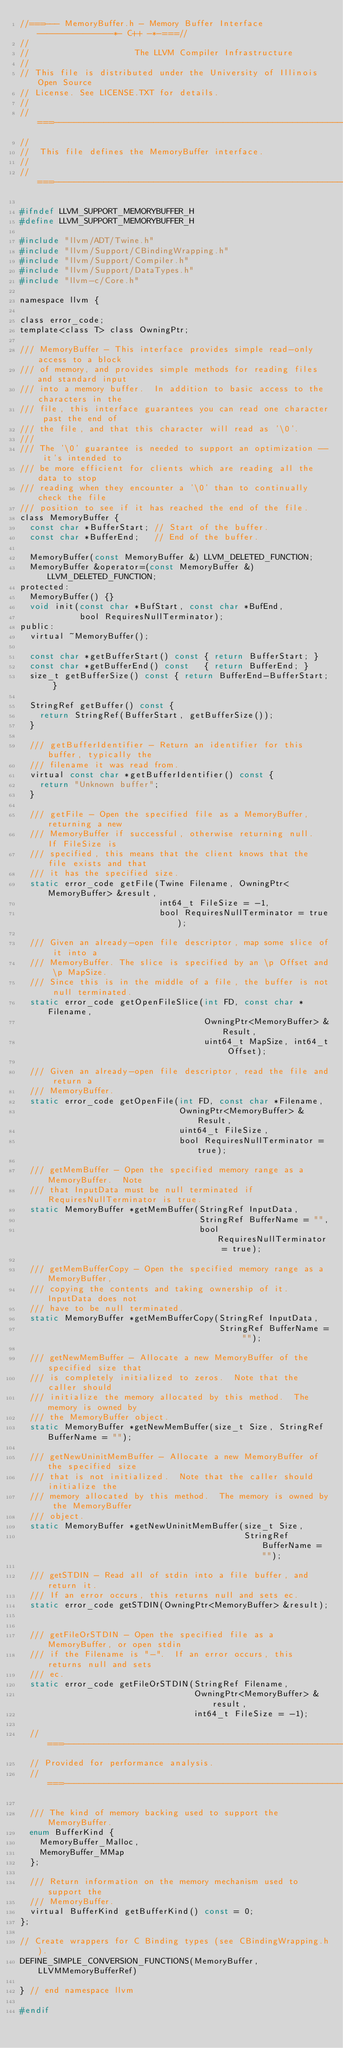<code> <loc_0><loc_0><loc_500><loc_500><_C_>//===--- MemoryBuffer.h - Memory Buffer Interface ---------------*- C++ -*-===//
//
//                     The LLVM Compiler Infrastructure
//
// This file is distributed under the University of Illinois Open Source
// License. See LICENSE.TXT for details.
//
//===----------------------------------------------------------------------===//
//
//  This file defines the MemoryBuffer interface.
//
//===----------------------------------------------------------------------===//

#ifndef LLVM_SUPPORT_MEMORYBUFFER_H
#define LLVM_SUPPORT_MEMORYBUFFER_H

#include "llvm/ADT/Twine.h"
#include "llvm/Support/CBindingWrapping.h"
#include "llvm/Support/Compiler.h"
#include "llvm/Support/DataTypes.h"
#include "llvm-c/Core.h"

namespace llvm {

class error_code;
template<class T> class OwningPtr;

/// MemoryBuffer - This interface provides simple read-only access to a block
/// of memory, and provides simple methods for reading files and standard input
/// into a memory buffer.  In addition to basic access to the characters in the
/// file, this interface guarantees you can read one character past the end of
/// the file, and that this character will read as '\0'.
///
/// The '\0' guarantee is needed to support an optimization -- it's intended to
/// be more efficient for clients which are reading all the data to stop
/// reading when they encounter a '\0' than to continually check the file
/// position to see if it has reached the end of the file.
class MemoryBuffer {
  const char *BufferStart; // Start of the buffer.
  const char *BufferEnd;   // End of the buffer.

  MemoryBuffer(const MemoryBuffer &) LLVM_DELETED_FUNCTION;
  MemoryBuffer &operator=(const MemoryBuffer &) LLVM_DELETED_FUNCTION;
protected:
  MemoryBuffer() {}
  void init(const char *BufStart, const char *BufEnd,
            bool RequiresNullTerminator);
public:
  virtual ~MemoryBuffer();

  const char *getBufferStart() const { return BufferStart; }
  const char *getBufferEnd() const   { return BufferEnd; }
  size_t getBufferSize() const { return BufferEnd-BufferStart; }

  StringRef getBuffer() const {
    return StringRef(BufferStart, getBufferSize());
  }

  /// getBufferIdentifier - Return an identifier for this buffer, typically the
  /// filename it was read from.
  virtual const char *getBufferIdentifier() const {
    return "Unknown buffer";
  }

  /// getFile - Open the specified file as a MemoryBuffer, returning a new
  /// MemoryBuffer if successful, otherwise returning null.  If FileSize is
  /// specified, this means that the client knows that the file exists and that
  /// it has the specified size.
  static error_code getFile(Twine Filename, OwningPtr<MemoryBuffer> &result,
                            int64_t FileSize = -1,
                            bool RequiresNullTerminator = true);

  /// Given an already-open file descriptor, map some slice of it into a
  /// MemoryBuffer. The slice is specified by an \p Offset and \p MapSize.
  /// Since this is in the middle of a file, the buffer is not null terminated.
  static error_code getOpenFileSlice(int FD, const char *Filename,
                                     OwningPtr<MemoryBuffer> &Result,
                                     uint64_t MapSize, int64_t Offset);

  /// Given an already-open file descriptor, read the file and return a
  /// MemoryBuffer.
  static error_code getOpenFile(int FD, const char *Filename,
                                OwningPtr<MemoryBuffer> &Result,
                                uint64_t FileSize,
                                bool RequiresNullTerminator = true);

  /// getMemBuffer - Open the specified memory range as a MemoryBuffer.  Note
  /// that InputData must be null terminated if RequiresNullTerminator is true.
  static MemoryBuffer *getMemBuffer(StringRef InputData,
                                    StringRef BufferName = "",
                                    bool RequiresNullTerminator = true);

  /// getMemBufferCopy - Open the specified memory range as a MemoryBuffer,
  /// copying the contents and taking ownership of it.  InputData does not
  /// have to be null terminated.
  static MemoryBuffer *getMemBufferCopy(StringRef InputData,
                                        StringRef BufferName = "");

  /// getNewMemBuffer - Allocate a new MemoryBuffer of the specified size that
  /// is completely initialized to zeros.  Note that the caller should
  /// initialize the memory allocated by this method.  The memory is owned by
  /// the MemoryBuffer object.
  static MemoryBuffer *getNewMemBuffer(size_t Size, StringRef BufferName = "");

  /// getNewUninitMemBuffer - Allocate a new MemoryBuffer of the specified size
  /// that is not initialized.  Note that the caller should initialize the
  /// memory allocated by this method.  The memory is owned by the MemoryBuffer
  /// object.
  static MemoryBuffer *getNewUninitMemBuffer(size_t Size,
                                             StringRef BufferName = "");

  /// getSTDIN - Read all of stdin into a file buffer, and return it.
  /// If an error occurs, this returns null and sets ec.
  static error_code getSTDIN(OwningPtr<MemoryBuffer> &result);


  /// getFileOrSTDIN - Open the specified file as a MemoryBuffer, or open stdin
  /// if the Filename is "-".  If an error occurs, this returns null and sets
  /// ec.
  static error_code getFileOrSTDIN(StringRef Filename,
                                   OwningPtr<MemoryBuffer> &result,
                                   int64_t FileSize = -1);

  //===--------------------------------------------------------------------===//
  // Provided for performance analysis.
  //===--------------------------------------------------------------------===//

  /// The kind of memory backing used to support the MemoryBuffer.
  enum BufferKind {
    MemoryBuffer_Malloc,
    MemoryBuffer_MMap
  };

  /// Return information on the memory mechanism used to support the
  /// MemoryBuffer.
  virtual BufferKind getBufferKind() const = 0;  
};

// Create wrappers for C Binding types (see CBindingWrapping.h).
DEFINE_SIMPLE_CONVERSION_FUNCTIONS(MemoryBuffer, LLVMMemoryBufferRef)

} // end namespace llvm

#endif
</code> 